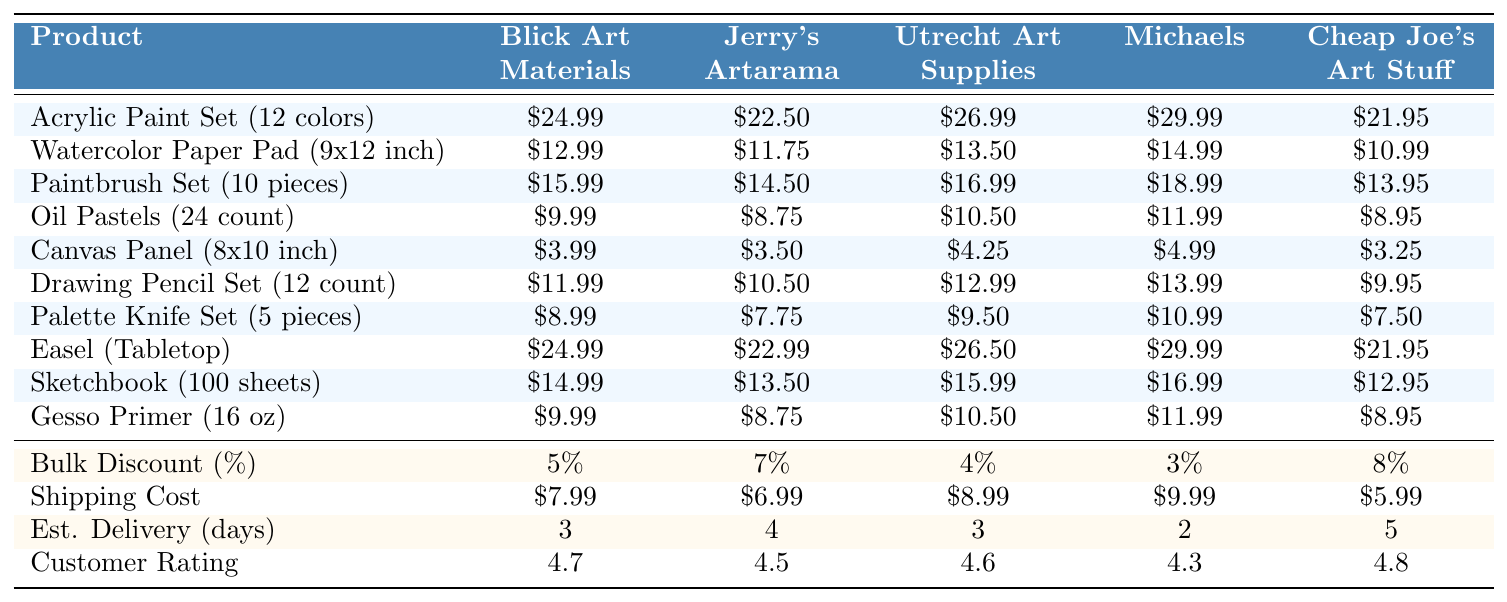What is the lowest price for the Acrylic Paint Set? The prices listed for the Acrylic Paint Set are $24.99 (Blick), $22.50 (Jerry's Artarama), $26.99 (Utrecht), $29.99 (Michaels), and $21.95 (Cheap Joe's). The lowest amount is $21.95 from Cheap Joe's.
Answer: $21.95 What is the shipping cost from Jerry's Artarama? The table lists the shipping cost for Jerry's Artarama as $6.99.
Answer: $6.99 How much would it cost to buy the Canvas Panel from Michaels including shipping? The price of the Canvas Panel from Michaels is $4.99. Adding the shipping cost of $9.99 gives $4.99 + $9.99 = $14.98.
Answer: $14.98 Which supplier offers the best bulk discount percentage? The bulk discount percentages are 5% (Blick), 7% (Jerry's Artarama), 4% (Utrecht), 3% (Michaels), and 8% (Cheap Joe's). The highest percentage is 8% from Cheap Joe's.
Answer: 8% What is the average price of the Watercolor Paper Pad across all suppliers? The prices for the Watercolor Paper Pad are $12.99 (Blick), $11.75 (Jerry's Artarama), $13.50 (Utrecht), $14.99 (Michaels), and $10.99 (Cheap Joe's). Their sum is $12.99 + $11.75 + $13.50 + $14.99 + $10.99 = $63.22, and the average is $63.22 / 5 = $12.644.
Answer: $12.64 Is the customer rating for Cheap Joe's higher than for Jerry's Artarama? Cheap Joe's rating is 4.8, while Jerry's Artarama is 4.5. Since 4.8 is greater than 4.5, the statement is true.
Answer: Yes Which product has the maximum price from Utrecht Art Supplies? The prices from Utrecht Art Supplies are $26.99 (Acrylic Paint Set), $13.50 (Watercolor Paper Pad), $16.99 (Paintbrush Set), $10.50 (Oil Pastels), $4.25 (Canvas Panel), $12.99 (Drawing Pencil Set), $9.50 (Palette Knife Set), $26.50 (Easel), $15.99 (Sketchbook), and $10.50 (Gesso Primer). The maximum price is $26.99 for the Acrylic Paint Set.
Answer: $26.99 If a customer buys both the Sketchbook and Gesso Primer from Blick, what is the total cost including shipping? The Sketchbook costs $14.99, and the Gesso Primer costs $9.99, totaling $14.99 + $9.99 = $24.98. Adding the shipping cost of $7.99 gives $24.98 + $7.99 = $32.97.
Answer: $32.97 Which supplier has the shortest estimated delivery time? The estimated delivery times are 3 days (Blick), 4 days (Jerry's Artarama), 3 days (Utrecht), 2 days (Michaels), and 5 days (Cheap Joe's). The shortest time is 2 days from Michaels.
Answer: 2 days Is the Paintbrush Set cheaper at Blick or Utrecht? The prices are $15.99 (Blick) and $16.99 (Utrecht). Since $15.99 is less than $16.99, the Paintbrush Set is cheaper at Blick.
Answer: Blick 